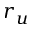<formula> <loc_0><loc_0><loc_500><loc_500>r _ { u }</formula> 